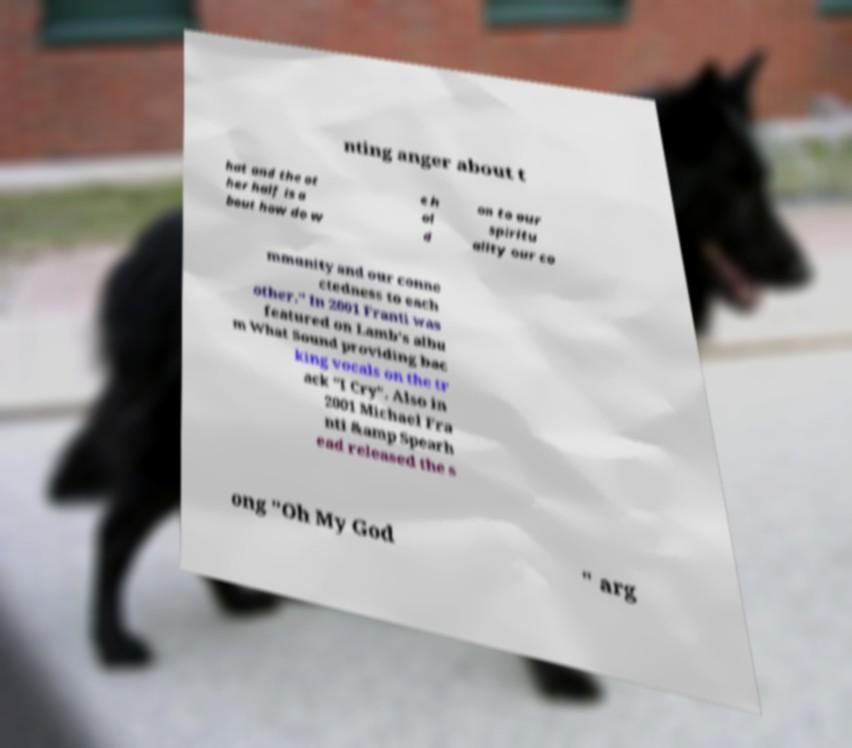What messages or text are displayed in this image? I need them in a readable, typed format. nting anger about t hat and the ot her half is a bout how do w e h ol d on to our spiritu ality our co mmunity and our conne ctedness to each other." In 2001 Franti was featured on Lamb's albu m What Sound providing bac king vocals on the tr ack "I Cry". Also in 2001 Michael Fra nti &amp Spearh ead released the s ong "Oh My God " arg 